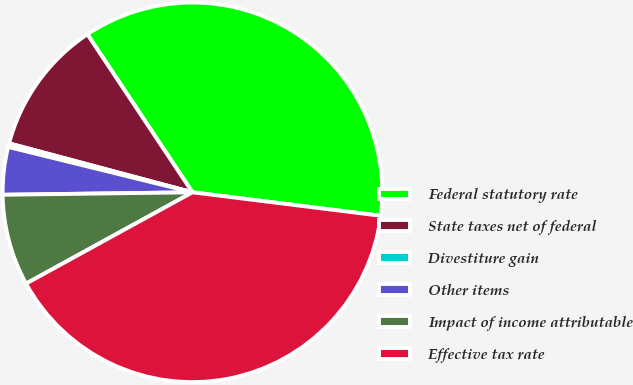<chart> <loc_0><loc_0><loc_500><loc_500><pie_chart><fcel>Federal statutory rate<fcel>State taxes net of federal<fcel>Divestiture gain<fcel>Other items<fcel>Impact of income attributable<fcel>Effective tax rate<nl><fcel>36.31%<fcel>11.51%<fcel>0.31%<fcel>4.05%<fcel>7.78%<fcel>40.04%<nl></chart> 